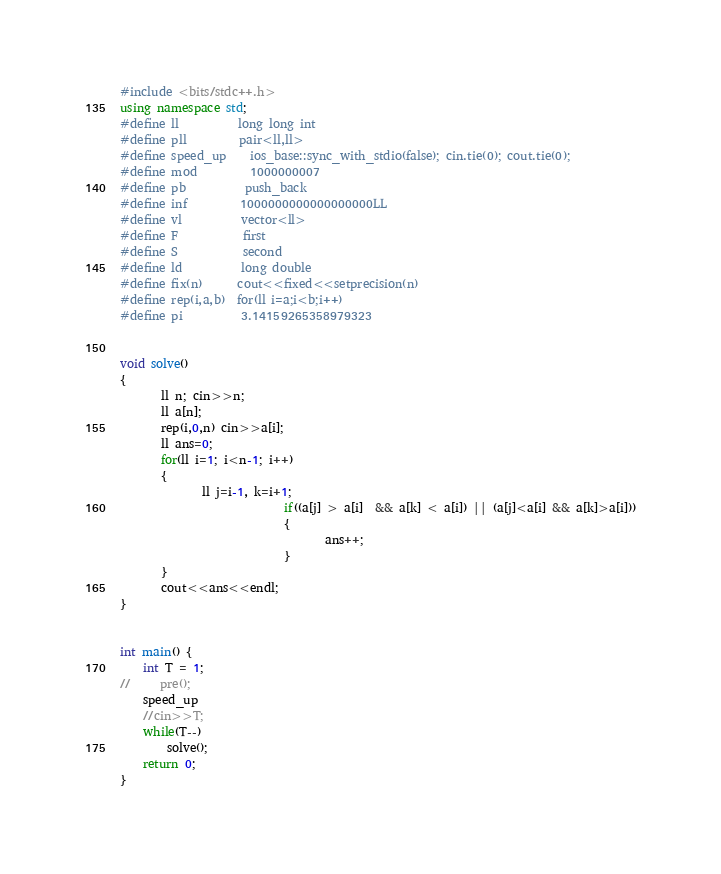<code> <loc_0><loc_0><loc_500><loc_500><_C++_>#include <bits/stdc++.h>
using namespace std;
#define ll          long long int
#define pll         pair<ll,ll>
#define speed_up    ios_base::sync_with_stdio(false); cin.tie(0); cout.tie(0);
#define mod         1000000007
#define pb          push_back
#define inf         1000000000000000000LL
#define vl          vector<ll>
#define F           first
#define S           second
#define ld          long double
#define fix(n)      cout<<fixed<<setprecision(n)
#define rep(i,a,b)  for(ll i=a;i<b;i++)
#define pi          3.14159265358979323


void solve()
{
       ll n; cin>>n;
       ll a[n];
       rep(i,0,n) cin>>a[i];
       ll ans=0;
       for(ll i=1; i<n-1; i++)
       {
              ll j=i-1, k=i+1;
                            if((a[j] > a[i]  && a[k] < a[i]) || (a[j]<a[i] && a[k]>a[i]))
                            {
                                   ans++;
                            }
       }
       cout<<ans<<endl;
}


int main() {
	int T = 1;
//     pre();
	speed_up
	//cin>>T;
	while(T--)
	    solve();
	return 0;
}
</code> 